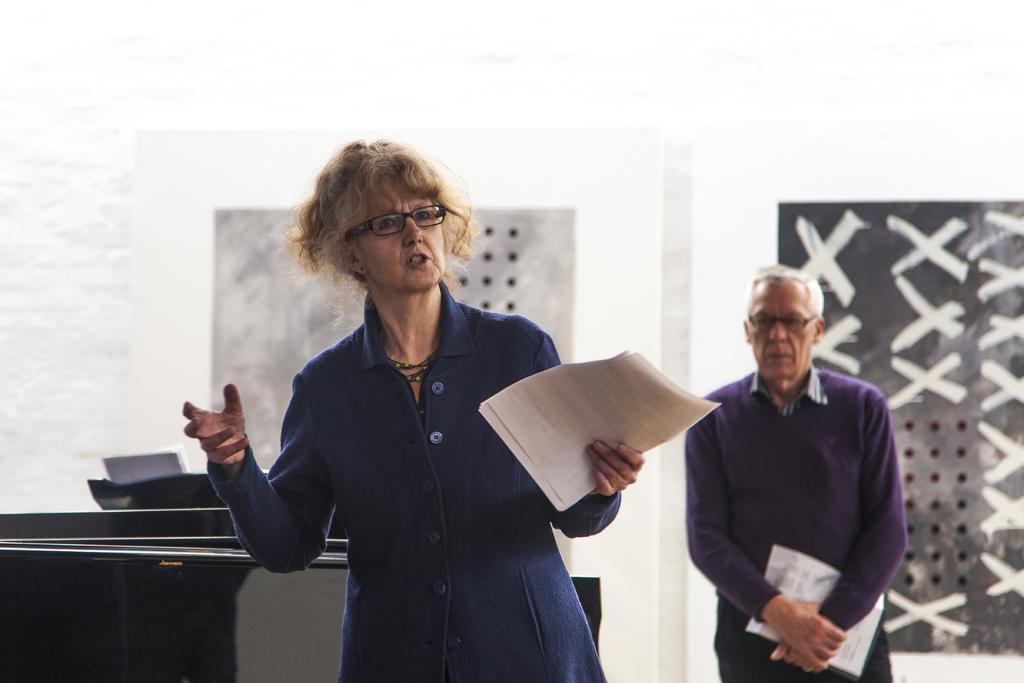Please provide a concise description of this image. In this image we can see people standing on the floor and holding papers in their hands. In the background there are walls. 